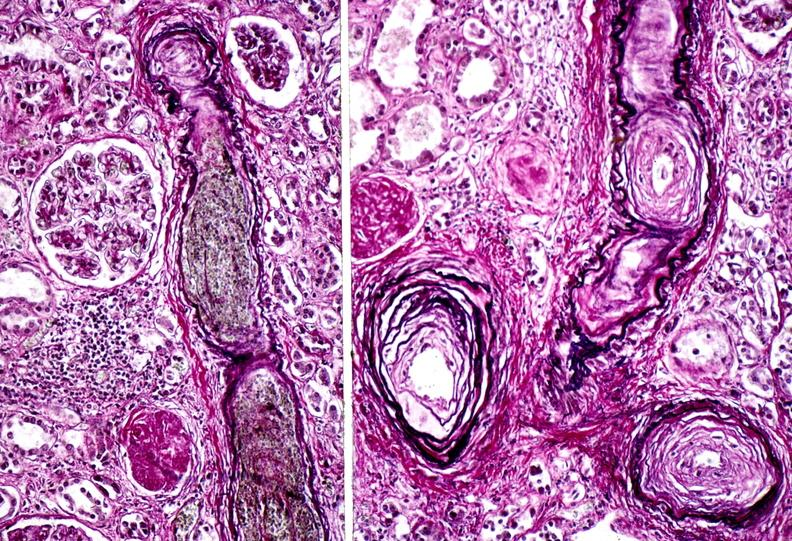what does this image show?
Answer the question using a single word or phrase. Kidney 